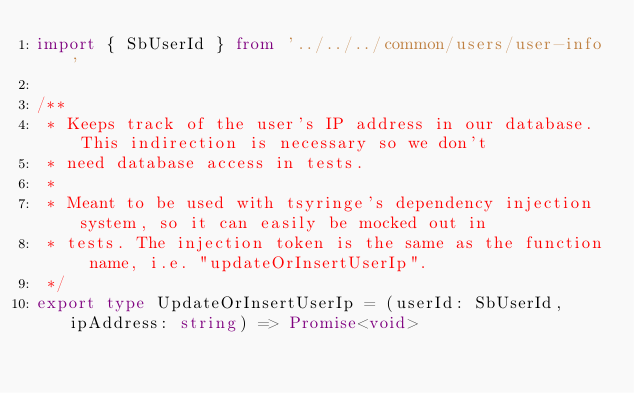Convert code to text. <code><loc_0><loc_0><loc_500><loc_500><_TypeScript_>import { SbUserId } from '../../../common/users/user-info'

/**
 * Keeps track of the user's IP address in our database. This indirection is necessary so we don't
 * need database access in tests.
 *
 * Meant to be used with tsyringe's dependency injection system, so it can easily be mocked out in
 * tests. The injection token is the same as the function name, i.e. "updateOrInsertUserIp".
 */
export type UpdateOrInsertUserIp = (userId: SbUserId, ipAddress: string) => Promise<void>
</code> 